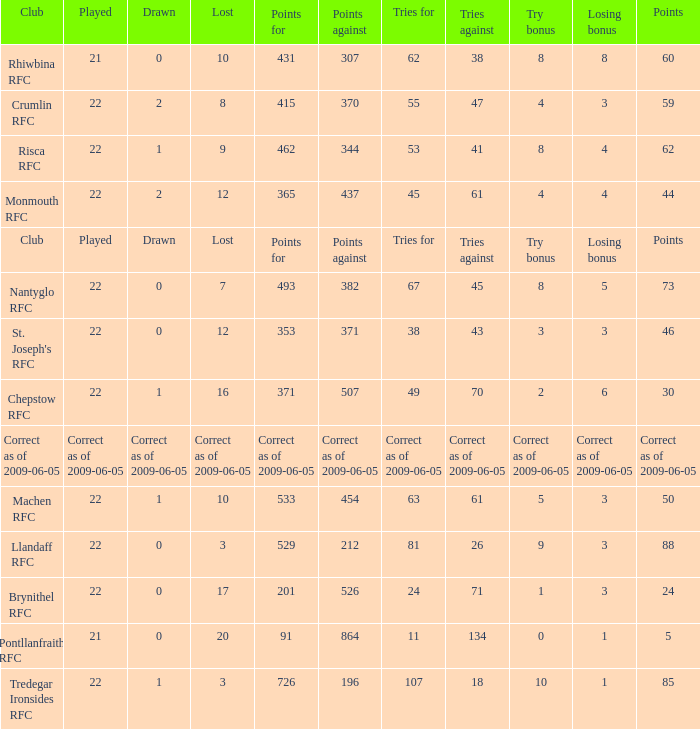If points against was 371, what is the drawn? 0.0. 